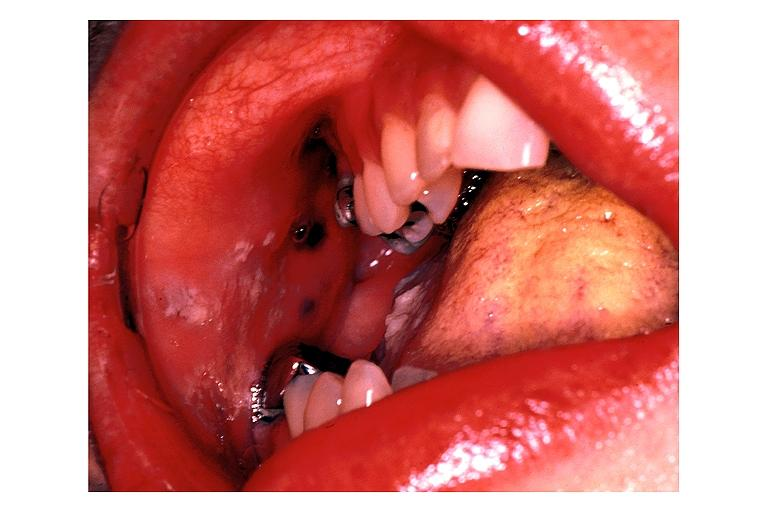what does this image show?
Answer the question using a single word or phrase. Peutz geghers syndrome 